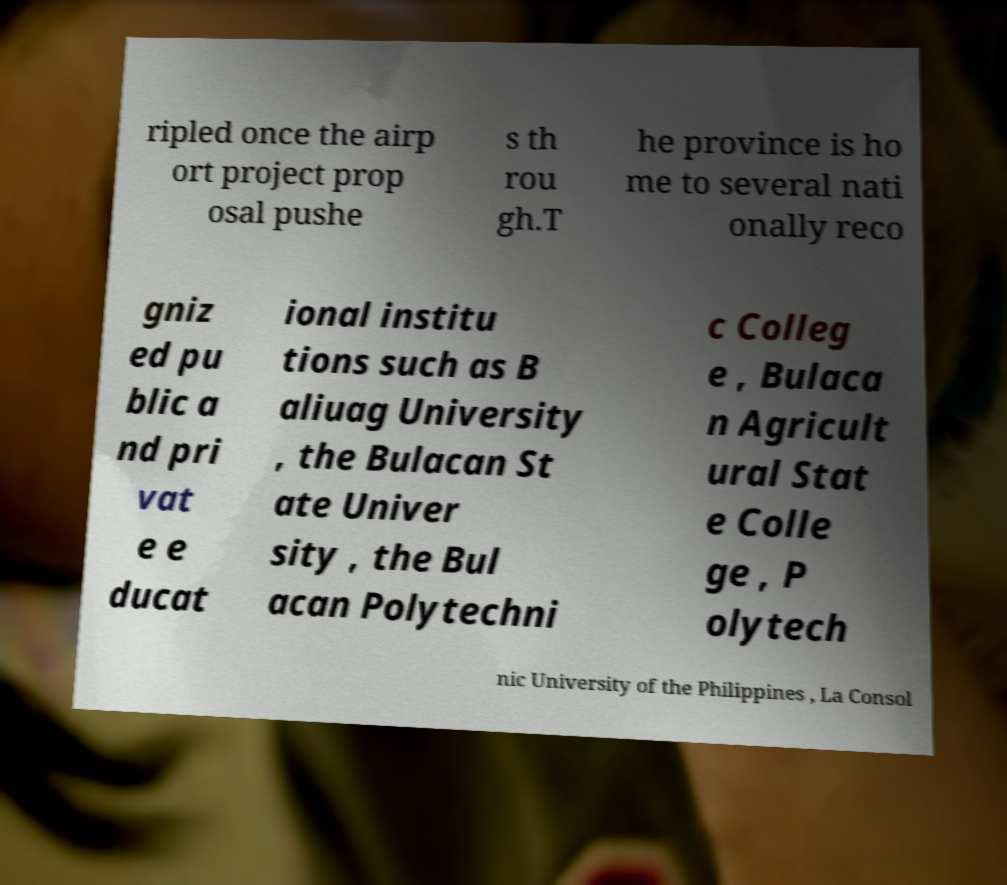Can you read and provide the text displayed in the image?This photo seems to have some interesting text. Can you extract and type it out for me? ripled once the airp ort project prop osal pushe s th rou gh.T he province is ho me to several nati onally reco gniz ed pu blic a nd pri vat e e ducat ional institu tions such as B aliuag University , the Bulacan St ate Univer sity , the Bul acan Polytechni c Colleg e , Bulaca n Agricult ural Stat e Colle ge , P olytech nic University of the Philippines , La Consol 